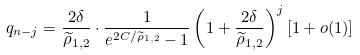<formula> <loc_0><loc_0><loc_500><loc_500>q _ { n - j } = \frac { 2 \delta } { \widetilde { \rho } _ { 1 , 2 } } \cdot \frac { 1 } { e ^ { 2 C / \widetilde { \rho } _ { 1 , 2 } } - 1 } \left ( 1 + \frac { 2 \delta } { \widetilde { \rho } _ { 1 , 2 } } \right ) ^ { j } [ 1 + o ( 1 ) ]</formula> 